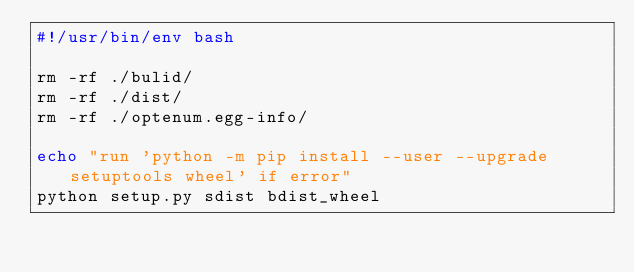<code> <loc_0><loc_0><loc_500><loc_500><_Bash_>#!/usr/bin/env bash

rm -rf ./bulid/
rm -rf ./dist/
rm -rf ./optenum.egg-info/

echo "run 'python -m pip install --user --upgrade setuptools wheel' if error"
python setup.py sdist bdist_wheel
</code> 